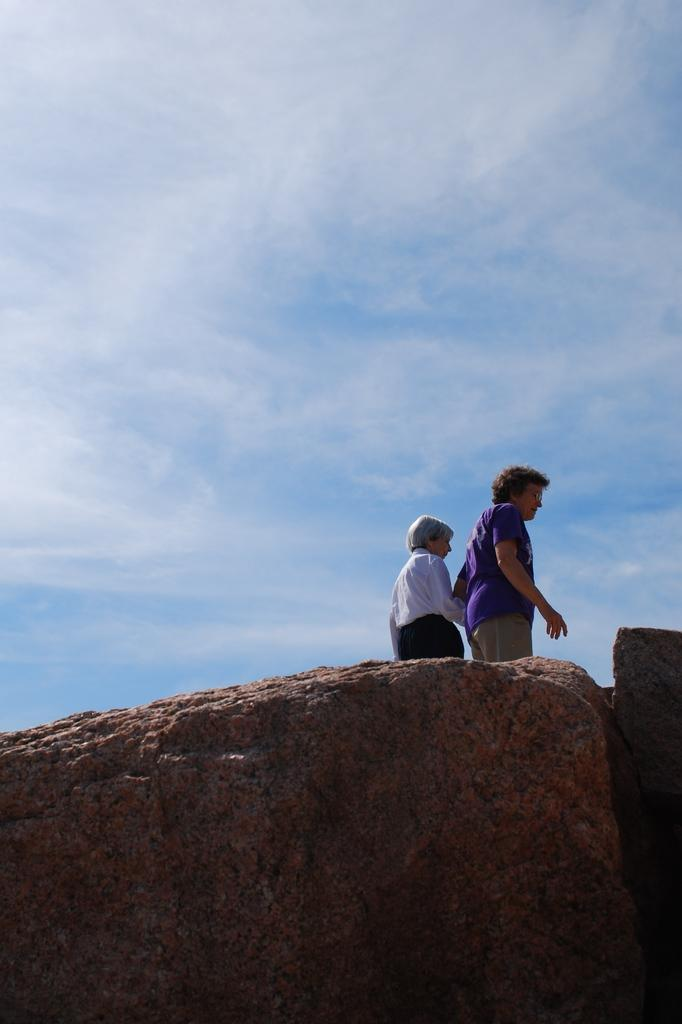What is the main object in the picture? There is a rock in the picture. What are the people in the picture doing? A: Two people are standing on the rock. What can be seen in the background of the picture? There is sky visible in the picture. What is the condition of the sky in the picture? Clouds are present in the sky. What type of plant is growing on the rock in the image? There is no plant growing on the rock in the image. Can you tell me how sharp the blade is that the people are holding in the image? There are no blades present in the image; the people are simply standing on the rock. 